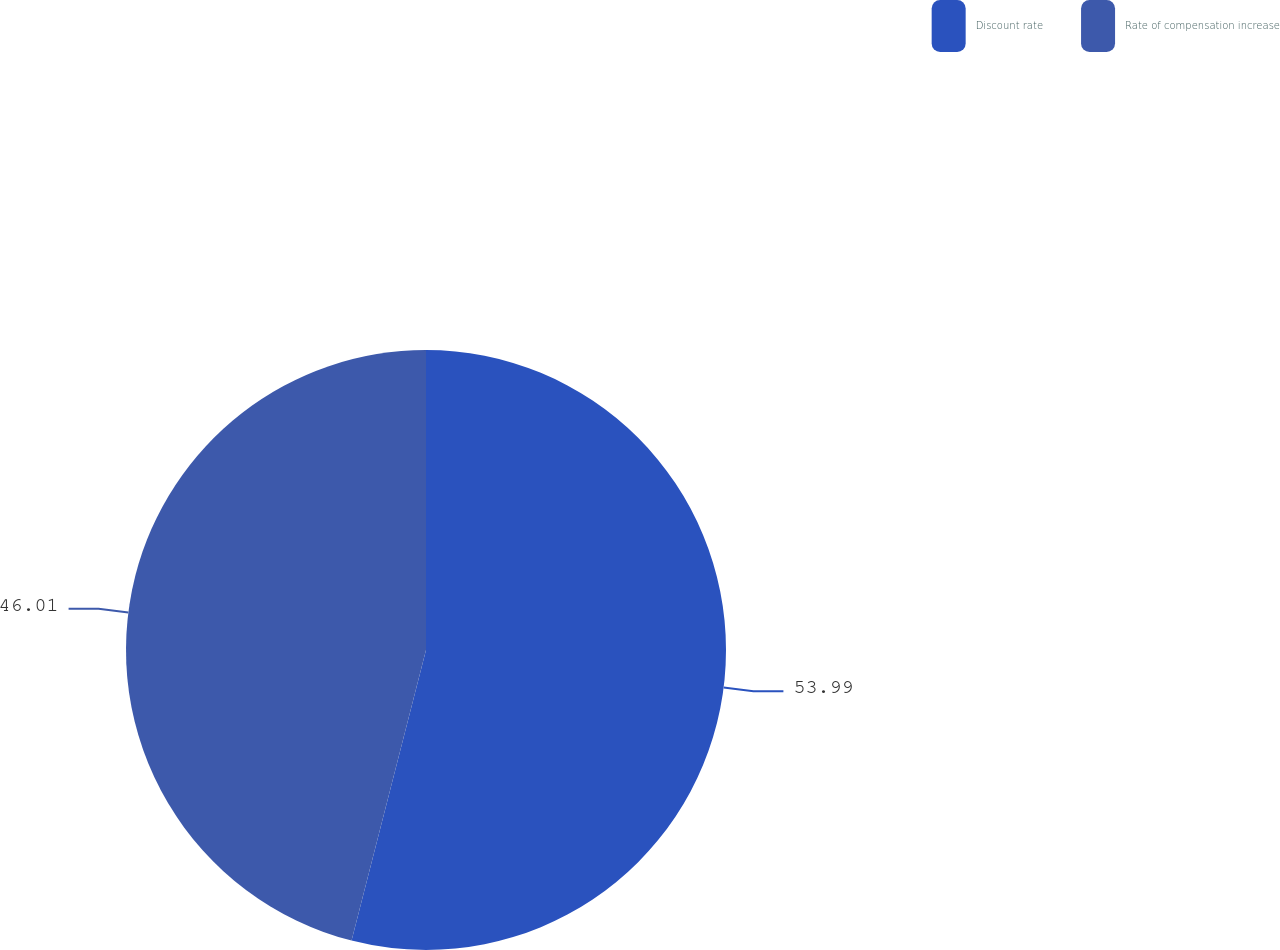Convert chart to OTSL. <chart><loc_0><loc_0><loc_500><loc_500><pie_chart><fcel>Discount rate<fcel>Rate of compensation increase<nl><fcel>53.99%<fcel>46.01%<nl></chart> 